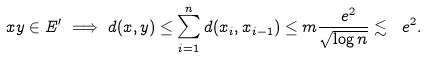<formula> <loc_0><loc_0><loc_500><loc_500>x y \in E ^ { \prime } \implies d ( x , y ) \leq \sum _ { i = 1 } ^ { n } d ( x _ { i } , x _ { i - 1 } ) \leq m \frac { \ e ^ { 2 } } { \sqrt { \log n } } \lesssim \ e ^ { 2 } .</formula> 